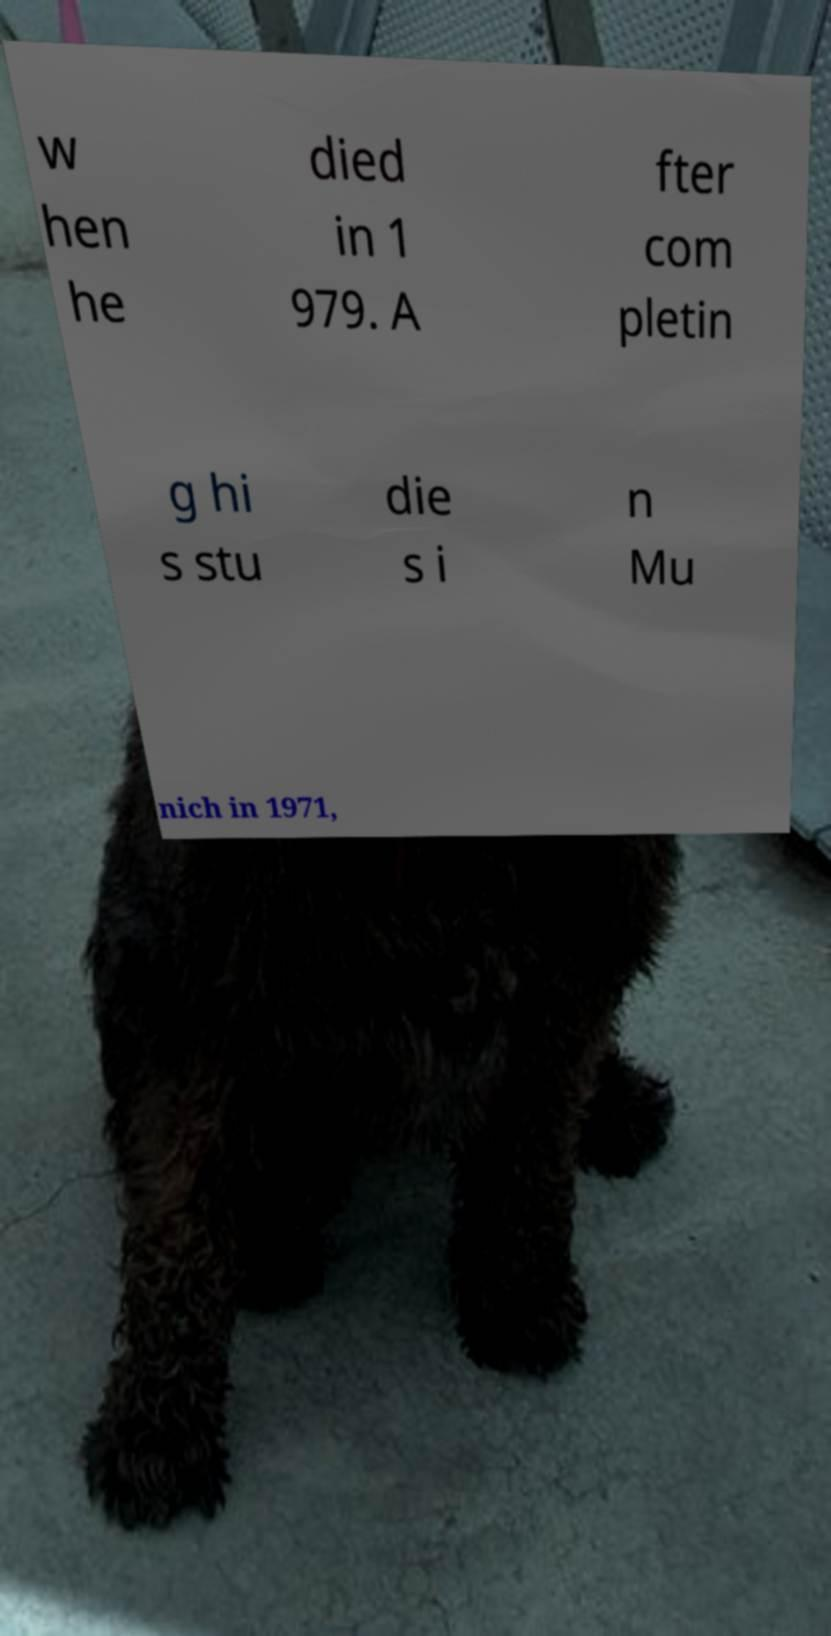I need the written content from this picture converted into text. Can you do that? w hen he died in 1 979. A fter com pletin g hi s stu die s i n Mu nich in 1971, 